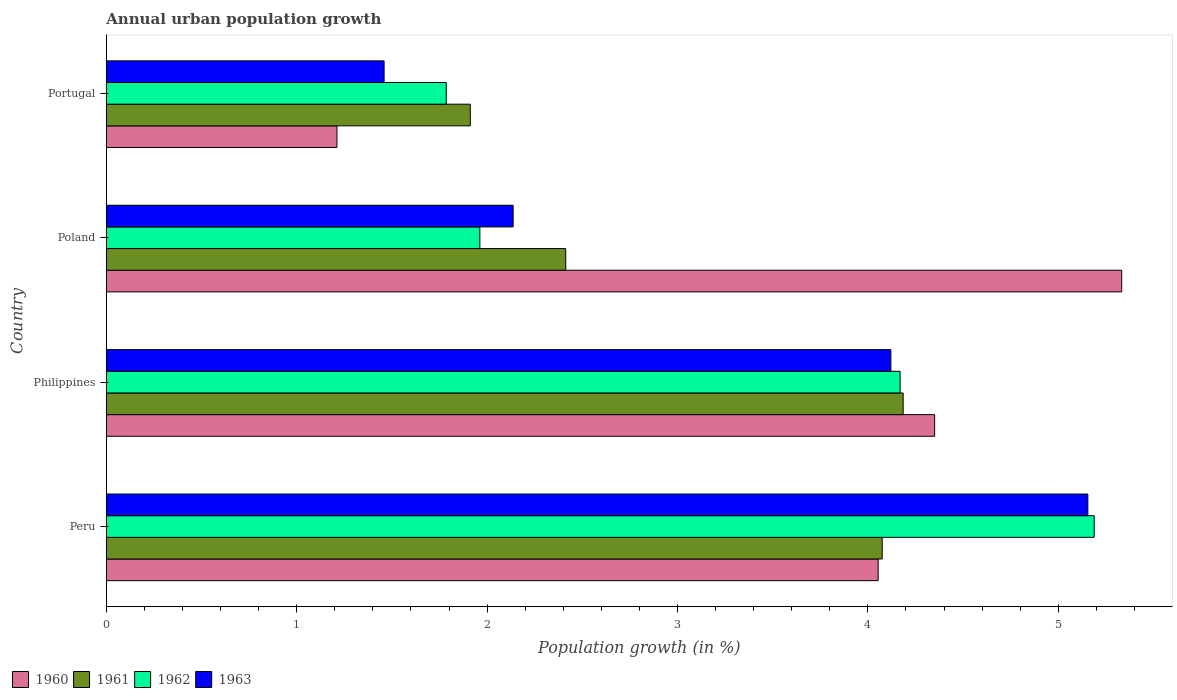Are the number of bars on each tick of the Y-axis equal?
Your response must be concise. Yes. In how many cases, is the number of bars for a given country not equal to the number of legend labels?
Make the answer very short. 0. What is the percentage of urban population growth in 1963 in Peru?
Provide a succinct answer. 5.16. Across all countries, what is the maximum percentage of urban population growth in 1962?
Provide a short and direct response. 5.19. Across all countries, what is the minimum percentage of urban population growth in 1961?
Offer a terse response. 1.91. In which country was the percentage of urban population growth in 1962 minimum?
Offer a very short reply. Portugal. What is the total percentage of urban population growth in 1961 in the graph?
Provide a short and direct response. 12.59. What is the difference between the percentage of urban population growth in 1960 in Philippines and that in Portugal?
Provide a short and direct response. 3.14. What is the difference between the percentage of urban population growth in 1960 in Poland and the percentage of urban population growth in 1961 in Philippines?
Your answer should be very brief. 1.15. What is the average percentage of urban population growth in 1962 per country?
Your answer should be very brief. 3.28. What is the difference between the percentage of urban population growth in 1962 and percentage of urban population growth in 1963 in Poland?
Make the answer very short. -0.17. In how many countries, is the percentage of urban population growth in 1960 greater than 1.2 %?
Keep it short and to the point. 4. What is the ratio of the percentage of urban population growth in 1961 in Peru to that in Philippines?
Keep it short and to the point. 0.97. Is the percentage of urban population growth in 1963 in Poland less than that in Portugal?
Give a very brief answer. No. Is the difference between the percentage of urban population growth in 1962 in Peru and Portugal greater than the difference between the percentage of urban population growth in 1963 in Peru and Portugal?
Your answer should be compact. No. What is the difference between the highest and the second highest percentage of urban population growth in 1961?
Your answer should be compact. 0.11. What is the difference between the highest and the lowest percentage of urban population growth in 1962?
Your answer should be very brief. 3.4. Is it the case that in every country, the sum of the percentage of urban population growth in 1963 and percentage of urban population growth in 1962 is greater than the sum of percentage of urban population growth in 1961 and percentage of urban population growth in 1960?
Provide a succinct answer. No. What does the 1st bar from the bottom in Portugal represents?
Give a very brief answer. 1960. Does the graph contain any zero values?
Provide a succinct answer. No. Does the graph contain grids?
Make the answer very short. No. Where does the legend appear in the graph?
Provide a succinct answer. Bottom left. How many legend labels are there?
Offer a terse response. 4. How are the legend labels stacked?
Your response must be concise. Horizontal. What is the title of the graph?
Offer a very short reply. Annual urban population growth. What is the label or title of the X-axis?
Provide a succinct answer. Population growth (in %). What is the label or title of the Y-axis?
Your answer should be compact. Country. What is the Population growth (in %) in 1960 in Peru?
Offer a very short reply. 4.05. What is the Population growth (in %) in 1961 in Peru?
Keep it short and to the point. 4.08. What is the Population growth (in %) in 1962 in Peru?
Give a very brief answer. 5.19. What is the Population growth (in %) of 1963 in Peru?
Your answer should be compact. 5.16. What is the Population growth (in %) of 1960 in Philippines?
Keep it short and to the point. 4.35. What is the Population growth (in %) of 1961 in Philippines?
Offer a very short reply. 4.19. What is the Population growth (in %) in 1962 in Philippines?
Provide a succinct answer. 4.17. What is the Population growth (in %) in 1963 in Philippines?
Give a very brief answer. 4.12. What is the Population growth (in %) of 1960 in Poland?
Make the answer very short. 5.33. What is the Population growth (in %) in 1961 in Poland?
Provide a succinct answer. 2.41. What is the Population growth (in %) of 1962 in Poland?
Your answer should be compact. 1.96. What is the Population growth (in %) in 1963 in Poland?
Give a very brief answer. 2.14. What is the Population growth (in %) in 1960 in Portugal?
Your answer should be compact. 1.21. What is the Population growth (in %) of 1961 in Portugal?
Your answer should be very brief. 1.91. What is the Population growth (in %) of 1962 in Portugal?
Offer a very short reply. 1.79. What is the Population growth (in %) in 1963 in Portugal?
Offer a very short reply. 1.46. Across all countries, what is the maximum Population growth (in %) of 1960?
Your answer should be compact. 5.33. Across all countries, what is the maximum Population growth (in %) of 1961?
Keep it short and to the point. 4.19. Across all countries, what is the maximum Population growth (in %) in 1962?
Make the answer very short. 5.19. Across all countries, what is the maximum Population growth (in %) in 1963?
Provide a short and direct response. 5.16. Across all countries, what is the minimum Population growth (in %) of 1960?
Your response must be concise. 1.21. Across all countries, what is the minimum Population growth (in %) in 1961?
Keep it short and to the point. 1.91. Across all countries, what is the minimum Population growth (in %) of 1962?
Offer a very short reply. 1.79. Across all countries, what is the minimum Population growth (in %) of 1963?
Your answer should be very brief. 1.46. What is the total Population growth (in %) in 1960 in the graph?
Keep it short and to the point. 14.95. What is the total Population growth (in %) of 1961 in the graph?
Give a very brief answer. 12.59. What is the total Population growth (in %) in 1962 in the graph?
Provide a succinct answer. 13.11. What is the total Population growth (in %) of 1963 in the graph?
Provide a short and direct response. 12.87. What is the difference between the Population growth (in %) of 1960 in Peru and that in Philippines?
Your answer should be compact. -0.3. What is the difference between the Population growth (in %) in 1961 in Peru and that in Philippines?
Your response must be concise. -0.11. What is the difference between the Population growth (in %) of 1962 in Peru and that in Philippines?
Offer a very short reply. 1.02. What is the difference between the Population growth (in %) of 1963 in Peru and that in Philippines?
Make the answer very short. 1.03. What is the difference between the Population growth (in %) in 1960 in Peru and that in Poland?
Give a very brief answer. -1.28. What is the difference between the Population growth (in %) of 1961 in Peru and that in Poland?
Your response must be concise. 1.66. What is the difference between the Population growth (in %) in 1962 in Peru and that in Poland?
Your answer should be compact. 3.23. What is the difference between the Population growth (in %) of 1963 in Peru and that in Poland?
Your response must be concise. 3.02. What is the difference between the Population growth (in %) of 1960 in Peru and that in Portugal?
Offer a very short reply. 2.84. What is the difference between the Population growth (in %) in 1961 in Peru and that in Portugal?
Your answer should be compact. 2.16. What is the difference between the Population growth (in %) of 1962 in Peru and that in Portugal?
Your response must be concise. 3.4. What is the difference between the Population growth (in %) in 1963 in Peru and that in Portugal?
Provide a succinct answer. 3.7. What is the difference between the Population growth (in %) in 1960 in Philippines and that in Poland?
Your response must be concise. -0.98. What is the difference between the Population growth (in %) of 1961 in Philippines and that in Poland?
Your answer should be compact. 1.77. What is the difference between the Population growth (in %) of 1962 in Philippines and that in Poland?
Keep it short and to the point. 2.21. What is the difference between the Population growth (in %) of 1963 in Philippines and that in Poland?
Your response must be concise. 1.98. What is the difference between the Population growth (in %) in 1960 in Philippines and that in Portugal?
Keep it short and to the point. 3.14. What is the difference between the Population growth (in %) in 1961 in Philippines and that in Portugal?
Ensure brevity in your answer.  2.27. What is the difference between the Population growth (in %) of 1962 in Philippines and that in Portugal?
Offer a terse response. 2.38. What is the difference between the Population growth (in %) in 1963 in Philippines and that in Portugal?
Give a very brief answer. 2.66. What is the difference between the Population growth (in %) in 1960 in Poland and that in Portugal?
Ensure brevity in your answer.  4.12. What is the difference between the Population growth (in %) of 1961 in Poland and that in Portugal?
Make the answer very short. 0.5. What is the difference between the Population growth (in %) of 1962 in Poland and that in Portugal?
Your answer should be compact. 0.18. What is the difference between the Population growth (in %) in 1963 in Poland and that in Portugal?
Make the answer very short. 0.68. What is the difference between the Population growth (in %) of 1960 in Peru and the Population growth (in %) of 1961 in Philippines?
Give a very brief answer. -0.13. What is the difference between the Population growth (in %) of 1960 in Peru and the Population growth (in %) of 1962 in Philippines?
Your answer should be very brief. -0.12. What is the difference between the Population growth (in %) in 1960 in Peru and the Population growth (in %) in 1963 in Philippines?
Provide a succinct answer. -0.07. What is the difference between the Population growth (in %) of 1961 in Peru and the Population growth (in %) of 1962 in Philippines?
Keep it short and to the point. -0.09. What is the difference between the Population growth (in %) of 1961 in Peru and the Population growth (in %) of 1963 in Philippines?
Your response must be concise. -0.05. What is the difference between the Population growth (in %) of 1962 in Peru and the Population growth (in %) of 1963 in Philippines?
Your response must be concise. 1.07. What is the difference between the Population growth (in %) of 1960 in Peru and the Population growth (in %) of 1961 in Poland?
Offer a terse response. 1.64. What is the difference between the Population growth (in %) of 1960 in Peru and the Population growth (in %) of 1962 in Poland?
Offer a very short reply. 2.09. What is the difference between the Population growth (in %) of 1960 in Peru and the Population growth (in %) of 1963 in Poland?
Give a very brief answer. 1.92. What is the difference between the Population growth (in %) of 1961 in Peru and the Population growth (in %) of 1962 in Poland?
Make the answer very short. 2.11. What is the difference between the Population growth (in %) of 1961 in Peru and the Population growth (in %) of 1963 in Poland?
Ensure brevity in your answer.  1.94. What is the difference between the Population growth (in %) in 1962 in Peru and the Population growth (in %) in 1963 in Poland?
Provide a short and direct response. 3.05. What is the difference between the Population growth (in %) in 1960 in Peru and the Population growth (in %) in 1961 in Portugal?
Offer a very short reply. 2.14. What is the difference between the Population growth (in %) of 1960 in Peru and the Population growth (in %) of 1962 in Portugal?
Your answer should be compact. 2.27. What is the difference between the Population growth (in %) in 1960 in Peru and the Population growth (in %) in 1963 in Portugal?
Ensure brevity in your answer.  2.6. What is the difference between the Population growth (in %) in 1961 in Peru and the Population growth (in %) in 1962 in Portugal?
Provide a succinct answer. 2.29. What is the difference between the Population growth (in %) in 1961 in Peru and the Population growth (in %) in 1963 in Portugal?
Your answer should be compact. 2.62. What is the difference between the Population growth (in %) in 1962 in Peru and the Population growth (in %) in 1963 in Portugal?
Provide a short and direct response. 3.73. What is the difference between the Population growth (in %) of 1960 in Philippines and the Population growth (in %) of 1961 in Poland?
Your response must be concise. 1.94. What is the difference between the Population growth (in %) of 1960 in Philippines and the Population growth (in %) of 1962 in Poland?
Your response must be concise. 2.39. What is the difference between the Population growth (in %) in 1960 in Philippines and the Population growth (in %) in 1963 in Poland?
Ensure brevity in your answer.  2.21. What is the difference between the Population growth (in %) of 1961 in Philippines and the Population growth (in %) of 1962 in Poland?
Give a very brief answer. 2.22. What is the difference between the Population growth (in %) of 1961 in Philippines and the Population growth (in %) of 1963 in Poland?
Your answer should be very brief. 2.05. What is the difference between the Population growth (in %) in 1962 in Philippines and the Population growth (in %) in 1963 in Poland?
Your response must be concise. 2.03. What is the difference between the Population growth (in %) in 1960 in Philippines and the Population growth (in %) in 1961 in Portugal?
Make the answer very short. 2.44. What is the difference between the Population growth (in %) in 1960 in Philippines and the Population growth (in %) in 1962 in Portugal?
Offer a terse response. 2.57. What is the difference between the Population growth (in %) in 1960 in Philippines and the Population growth (in %) in 1963 in Portugal?
Your response must be concise. 2.89. What is the difference between the Population growth (in %) of 1961 in Philippines and the Population growth (in %) of 1962 in Portugal?
Offer a very short reply. 2.4. What is the difference between the Population growth (in %) in 1961 in Philippines and the Population growth (in %) in 1963 in Portugal?
Make the answer very short. 2.73. What is the difference between the Population growth (in %) of 1962 in Philippines and the Population growth (in %) of 1963 in Portugal?
Your answer should be very brief. 2.71. What is the difference between the Population growth (in %) in 1960 in Poland and the Population growth (in %) in 1961 in Portugal?
Your answer should be compact. 3.42. What is the difference between the Population growth (in %) in 1960 in Poland and the Population growth (in %) in 1962 in Portugal?
Your answer should be compact. 3.55. What is the difference between the Population growth (in %) of 1960 in Poland and the Population growth (in %) of 1963 in Portugal?
Give a very brief answer. 3.87. What is the difference between the Population growth (in %) of 1961 in Poland and the Population growth (in %) of 1962 in Portugal?
Your answer should be very brief. 0.63. What is the difference between the Population growth (in %) in 1961 in Poland and the Population growth (in %) in 1963 in Portugal?
Your answer should be compact. 0.95. What is the difference between the Population growth (in %) in 1962 in Poland and the Population growth (in %) in 1963 in Portugal?
Your answer should be very brief. 0.5. What is the average Population growth (in %) in 1960 per country?
Ensure brevity in your answer.  3.74. What is the average Population growth (in %) of 1961 per country?
Offer a terse response. 3.15. What is the average Population growth (in %) in 1962 per country?
Offer a very short reply. 3.28. What is the average Population growth (in %) of 1963 per country?
Make the answer very short. 3.22. What is the difference between the Population growth (in %) in 1960 and Population growth (in %) in 1961 in Peru?
Your answer should be compact. -0.02. What is the difference between the Population growth (in %) in 1960 and Population growth (in %) in 1962 in Peru?
Make the answer very short. -1.13. What is the difference between the Population growth (in %) of 1960 and Population growth (in %) of 1963 in Peru?
Provide a short and direct response. -1.1. What is the difference between the Population growth (in %) in 1961 and Population growth (in %) in 1962 in Peru?
Your answer should be compact. -1.11. What is the difference between the Population growth (in %) of 1961 and Population growth (in %) of 1963 in Peru?
Provide a short and direct response. -1.08. What is the difference between the Population growth (in %) of 1960 and Population growth (in %) of 1961 in Philippines?
Offer a terse response. 0.17. What is the difference between the Population growth (in %) in 1960 and Population growth (in %) in 1962 in Philippines?
Offer a very short reply. 0.18. What is the difference between the Population growth (in %) of 1960 and Population growth (in %) of 1963 in Philippines?
Offer a terse response. 0.23. What is the difference between the Population growth (in %) in 1961 and Population growth (in %) in 1962 in Philippines?
Your response must be concise. 0.02. What is the difference between the Population growth (in %) of 1961 and Population growth (in %) of 1963 in Philippines?
Give a very brief answer. 0.06. What is the difference between the Population growth (in %) in 1962 and Population growth (in %) in 1963 in Philippines?
Give a very brief answer. 0.05. What is the difference between the Population growth (in %) of 1960 and Population growth (in %) of 1961 in Poland?
Make the answer very short. 2.92. What is the difference between the Population growth (in %) in 1960 and Population growth (in %) in 1962 in Poland?
Provide a succinct answer. 3.37. What is the difference between the Population growth (in %) of 1960 and Population growth (in %) of 1963 in Poland?
Provide a succinct answer. 3.2. What is the difference between the Population growth (in %) of 1961 and Population growth (in %) of 1962 in Poland?
Give a very brief answer. 0.45. What is the difference between the Population growth (in %) in 1961 and Population growth (in %) in 1963 in Poland?
Keep it short and to the point. 0.28. What is the difference between the Population growth (in %) of 1962 and Population growth (in %) of 1963 in Poland?
Make the answer very short. -0.17. What is the difference between the Population growth (in %) in 1960 and Population growth (in %) in 1961 in Portugal?
Make the answer very short. -0.7. What is the difference between the Population growth (in %) of 1960 and Population growth (in %) of 1962 in Portugal?
Make the answer very short. -0.57. What is the difference between the Population growth (in %) of 1960 and Population growth (in %) of 1963 in Portugal?
Offer a very short reply. -0.25. What is the difference between the Population growth (in %) of 1961 and Population growth (in %) of 1962 in Portugal?
Provide a succinct answer. 0.13. What is the difference between the Population growth (in %) in 1961 and Population growth (in %) in 1963 in Portugal?
Your response must be concise. 0.45. What is the difference between the Population growth (in %) in 1962 and Population growth (in %) in 1963 in Portugal?
Give a very brief answer. 0.33. What is the ratio of the Population growth (in %) in 1960 in Peru to that in Philippines?
Give a very brief answer. 0.93. What is the ratio of the Population growth (in %) of 1961 in Peru to that in Philippines?
Give a very brief answer. 0.97. What is the ratio of the Population growth (in %) in 1962 in Peru to that in Philippines?
Provide a succinct answer. 1.24. What is the ratio of the Population growth (in %) in 1963 in Peru to that in Philippines?
Give a very brief answer. 1.25. What is the ratio of the Population growth (in %) of 1960 in Peru to that in Poland?
Make the answer very short. 0.76. What is the ratio of the Population growth (in %) in 1961 in Peru to that in Poland?
Provide a succinct answer. 1.69. What is the ratio of the Population growth (in %) in 1962 in Peru to that in Poland?
Ensure brevity in your answer.  2.64. What is the ratio of the Population growth (in %) of 1963 in Peru to that in Poland?
Give a very brief answer. 2.41. What is the ratio of the Population growth (in %) in 1960 in Peru to that in Portugal?
Provide a short and direct response. 3.35. What is the ratio of the Population growth (in %) of 1961 in Peru to that in Portugal?
Your answer should be compact. 2.13. What is the ratio of the Population growth (in %) of 1962 in Peru to that in Portugal?
Provide a short and direct response. 2.91. What is the ratio of the Population growth (in %) of 1963 in Peru to that in Portugal?
Keep it short and to the point. 3.53. What is the ratio of the Population growth (in %) of 1960 in Philippines to that in Poland?
Your answer should be compact. 0.82. What is the ratio of the Population growth (in %) of 1961 in Philippines to that in Poland?
Provide a succinct answer. 1.73. What is the ratio of the Population growth (in %) in 1962 in Philippines to that in Poland?
Provide a succinct answer. 2.12. What is the ratio of the Population growth (in %) in 1963 in Philippines to that in Poland?
Make the answer very short. 1.93. What is the ratio of the Population growth (in %) of 1960 in Philippines to that in Portugal?
Provide a short and direct response. 3.59. What is the ratio of the Population growth (in %) of 1961 in Philippines to that in Portugal?
Your answer should be very brief. 2.19. What is the ratio of the Population growth (in %) of 1962 in Philippines to that in Portugal?
Your response must be concise. 2.34. What is the ratio of the Population growth (in %) in 1963 in Philippines to that in Portugal?
Your response must be concise. 2.82. What is the ratio of the Population growth (in %) of 1960 in Poland to that in Portugal?
Your answer should be very brief. 4.4. What is the ratio of the Population growth (in %) of 1961 in Poland to that in Portugal?
Provide a succinct answer. 1.26. What is the ratio of the Population growth (in %) in 1962 in Poland to that in Portugal?
Keep it short and to the point. 1.1. What is the ratio of the Population growth (in %) of 1963 in Poland to that in Portugal?
Make the answer very short. 1.46. What is the difference between the highest and the second highest Population growth (in %) in 1960?
Keep it short and to the point. 0.98. What is the difference between the highest and the second highest Population growth (in %) of 1961?
Your response must be concise. 0.11. What is the difference between the highest and the second highest Population growth (in %) of 1962?
Give a very brief answer. 1.02. What is the difference between the highest and the second highest Population growth (in %) in 1963?
Give a very brief answer. 1.03. What is the difference between the highest and the lowest Population growth (in %) of 1960?
Provide a succinct answer. 4.12. What is the difference between the highest and the lowest Population growth (in %) of 1961?
Ensure brevity in your answer.  2.27. What is the difference between the highest and the lowest Population growth (in %) in 1962?
Your answer should be compact. 3.4. What is the difference between the highest and the lowest Population growth (in %) in 1963?
Your answer should be compact. 3.7. 